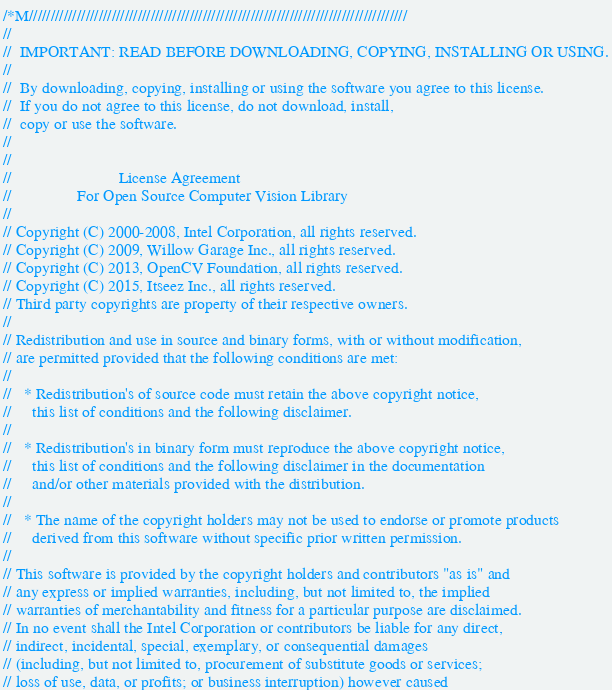<code> <loc_0><loc_0><loc_500><loc_500><_C++_>/*M///////////////////////////////////////////////////////////////////////////////////////
//
//  IMPORTANT: READ BEFORE DOWNLOADING, COPYING, INSTALLING OR USING.
//
//  By downloading, copying, installing or using the software you agree to this license.
//  If you do not agree to this license, do not download, install,
//  copy or use the software.
//
//
//                          License Agreement
//                For Open Source Computer Vision Library
//
// Copyright (C) 2000-2008, Intel Corporation, all rights reserved.
// Copyright (C) 2009, Willow Garage Inc., all rights reserved.
// Copyright (C) 2013, OpenCV Foundation, all rights reserved.
// Copyright (C) 2015, Itseez Inc., all rights reserved.
// Third party copyrights are property of their respective owners.
//
// Redistribution and use in source and binary forms, with or without modification,
// are permitted provided that the following conditions are met:
//
//   * Redistribution's of source code must retain the above copyright notice,
//     this list of conditions and the following disclaimer.
//
//   * Redistribution's in binary form must reproduce the above copyright notice,
//     this list of conditions and the following disclaimer in the documentation
//     and/or other materials provided with the distribution.
//
//   * The name of the copyright holders may not be used to endorse or promote products
//     derived from this software without specific prior written permission.
//
// This software is provided by the copyright holders and contributors "as is" and
// any express or implied warranties, including, but not limited to, the implied
// warranties of merchantability and fitness for a particular purpose are disclaimed.
// In no event shall the Intel Corporation or contributors be liable for any direct,
// indirect, incidental, special, exemplary, or consequential damages
// (including, but not limited to, procurement of substitute goods or services;
// loss of use, data, or profits; or business interruption) however caused</code> 